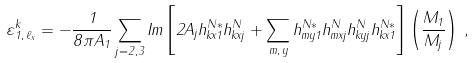Convert formula to latex. <formula><loc_0><loc_0><loc_500><loc_500>\varepsilon ^ { k } _ { 1 , \, \ell _ { x } } = - \frac { 1 } { 8 \pi A _ { 1 } } \sum _ { j = 2 , 3 } I m \left [ 2 A _ { j } h ^ { N * } _ { k x 1 } h ^ { N } _ { k x j } + \sum _ { m , \, y } h ^ { N * } _ { m y 1 } h ^ { N } _ { m x j } h ^ { N } _ { k y j } h ^ { N * } _ { k x 1 } \right ] \left ( \frac { M _ { 1 } } { M _ { j } } \right ) \, ,</formula> 